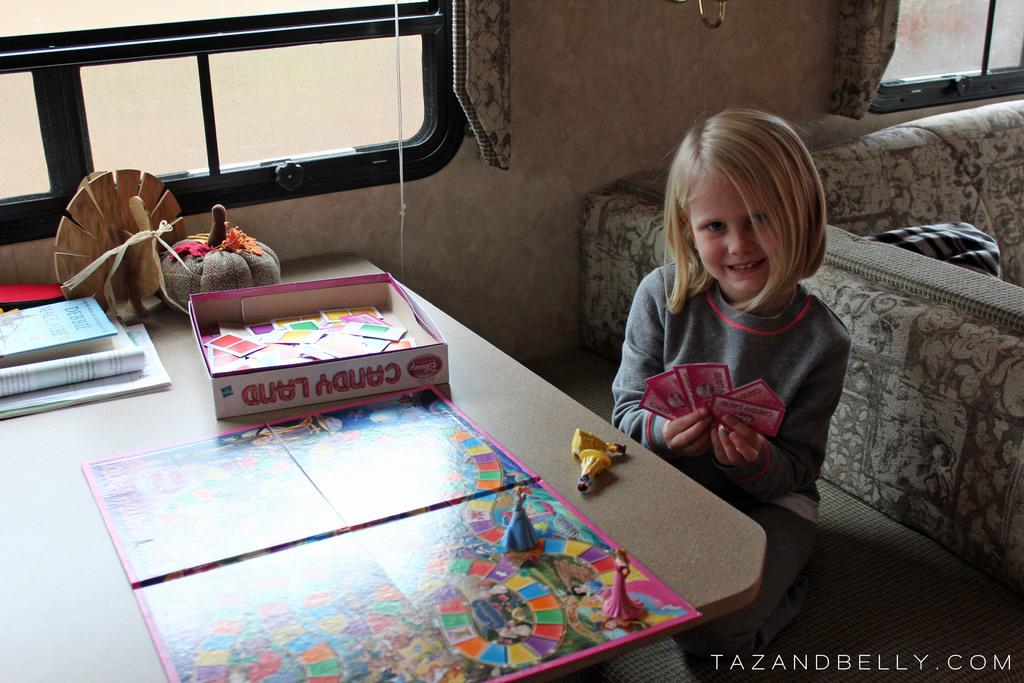Provide a one-sentence caption for the provided image. A girl playing candyland inside of a camper, ath the table. 